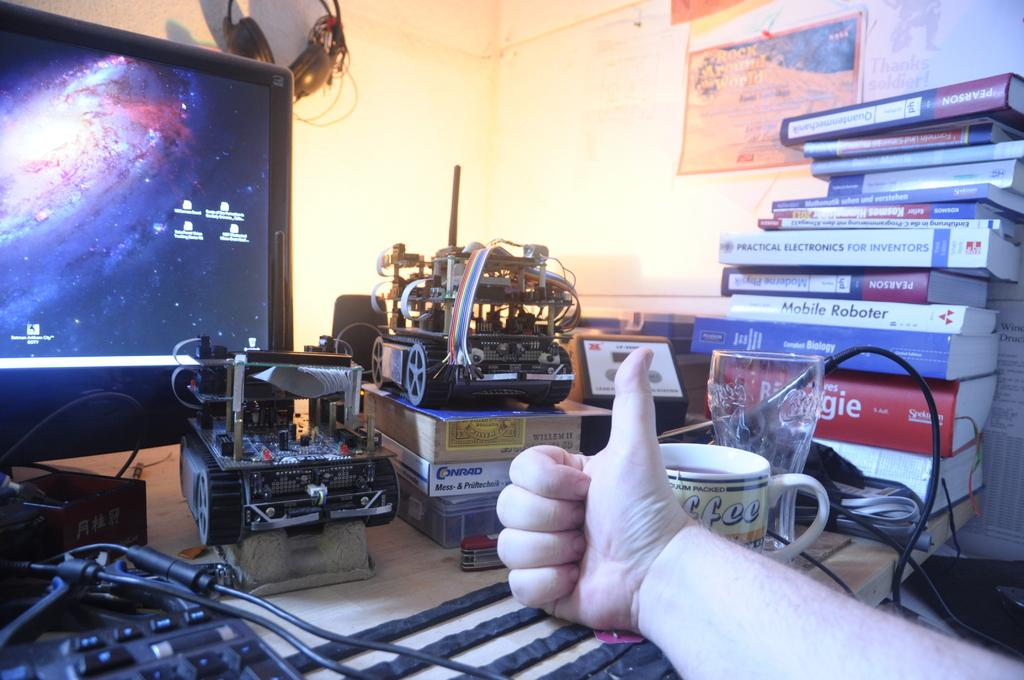Provide a one-sentence caption for the provided image. A book called Mobile Roboter sits in a stack of books on someone's desk. 